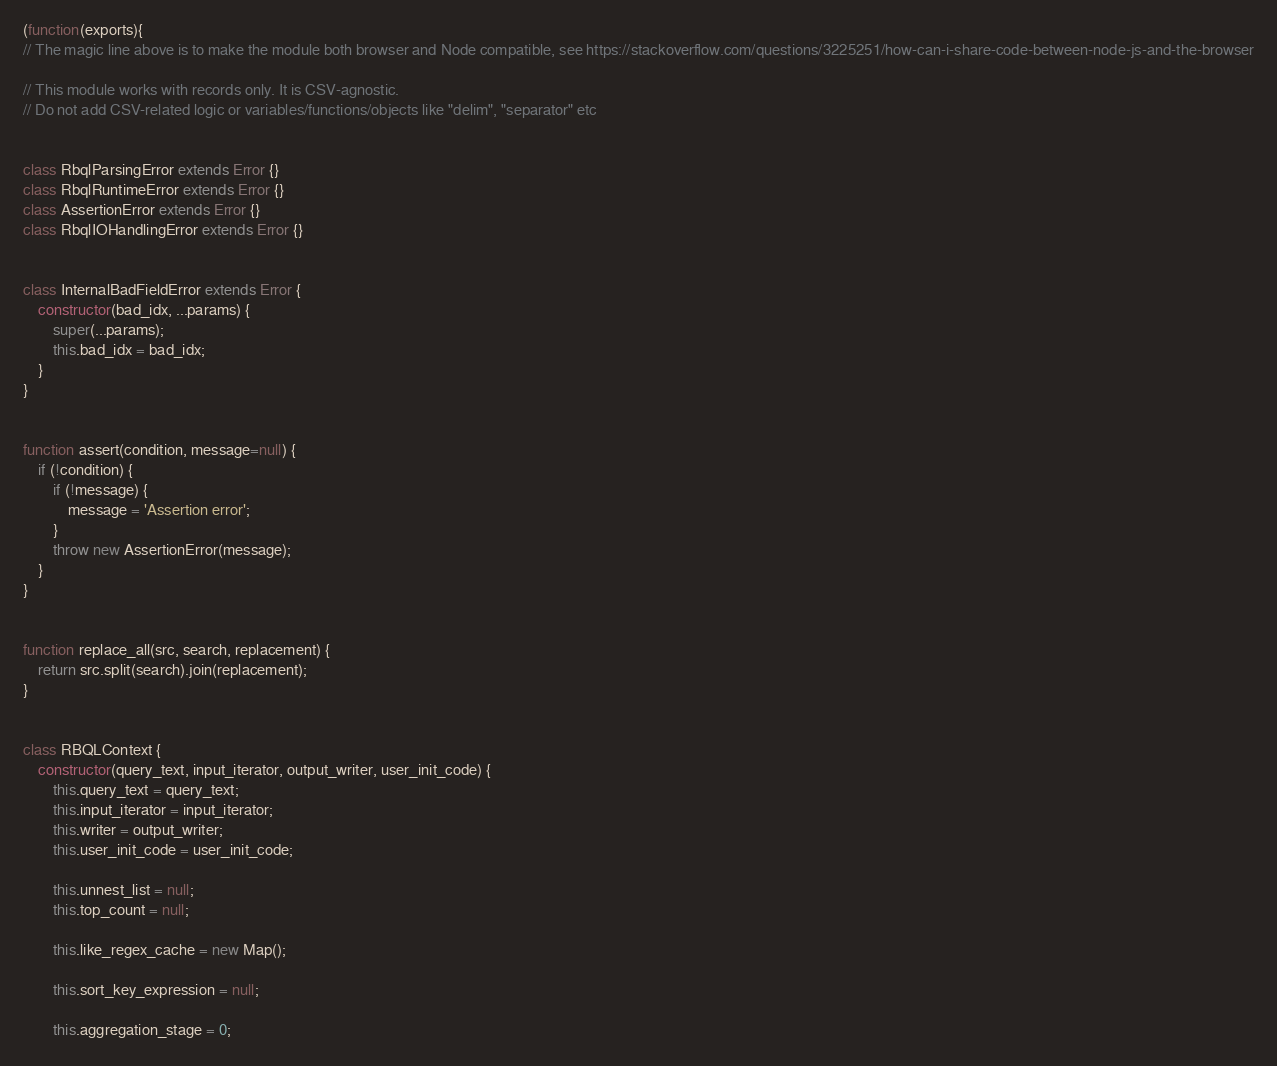<code> <loc_0><loc_0><loc_500><loc_500><_JavaScript_>(function(exports){
// The magic line above is to make the module both browser and Node compatible, see https://stackoverflow.com/questions/3225251/how-can-i-share-code-between-node-js-and-the-browser

// This module works with records only. It is CSV-agnostic.
// Do not add CSV-related logic or variables/functions/objects like "delim", "separator" etc


class RbqlParsingError extends Error {}
class RbqlRuntimeError extends Error {}
class AssertionError extends Error {}
class RbqlIOHandlingError extends Error {}


class InternalBadFieldError extends Error {
    constructor(bad_idx, ...params) {
        super(...params);
        this.bad_idx = bad_idx;
    }
}


function assert(condition, message=null) {
    if (!condition) {
        if (!message) {
            message = 'Assertion error';
        }
        throw new AssertionError(message);
    }
}


function replace_all(src, search, replacement) {
    return src.split(search).join(replacement);
}


class RBQLContext {
    constructor(query_text, input_iterator, output_writer, user_init_code) {
        this.query_text = query_text;
        this.input_iterator = input_iterator;
        this.writer = output_writer;
        this.user_init_code = user_init_code;

        this.unnest_list = null;
        this.top_count = null;

        this.like_regex_cache = new Map();

        this.sort_key_expression = null;

        this.aggregation_stage = 0;</code> 